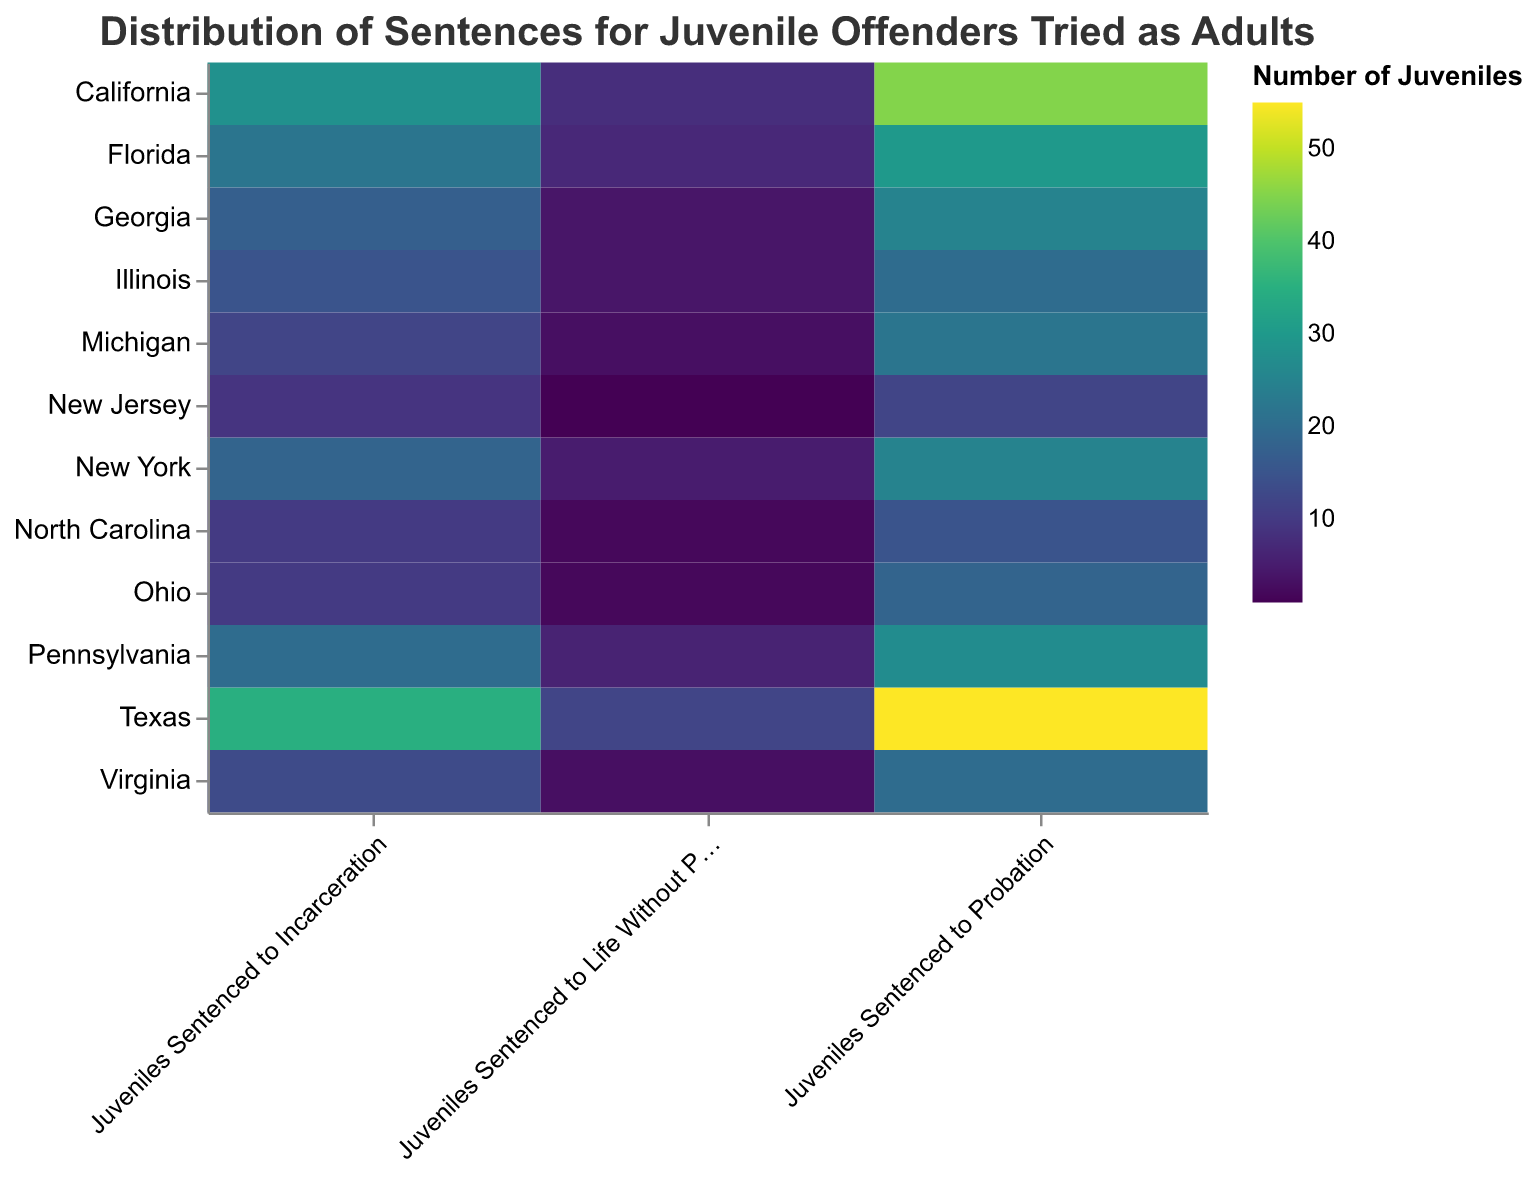What is the title of the figure? The title is typically found at the top of the figure. For this heatmap, it is clearly stated at the top.
Answer: Distribution of Sentences for Juvenile Offenders Tried as Adults Which state has the highest number of juveniles sentenced to probation? You can determine this by looking at the darkest color under the "Juveniles Sentenced to Probation" row. The state with the darkest color is Texas.
Answer: Texas How many states have juveniles sentenced to life without parole? Count the number of states listed on the y-axis where there is a color in the "Juveniles Sentenced to Life Without Parole" column.
Answer: 12 What is the total number of juveniles sentenced to incarceration in California and Texas combined? To calculate this, find the number of juveniles sentenced to incarceration in California (28) and Texas (35), and then add them together: 28 + 35 = 63.
Answer: 63 Which state has the least number of juveniles sentenced to life without parole? Look for the state with the lightest color under the "Juveniles Sentenced to Life Without Parole" column. New Jersey has the lightest color with only 1 juvenile sentenced to life without parole.
Answer: New Jersey Compare the number of juveniles sentenced to probation in Florida and New York. Which state has more? Locate the counts for Florida (30) and New York (25) under the "Juveniles Sentenced to Probation" column, and compare them. Florida has more juveniles sentenced to probation than New York.
Answer: Florida How many more juveniles are sentenced to life without parole in Texas than in Ohio? Find the counts for Texas (12) and Ohio (2) under the "Juveniles Sentenced to Life Without Parole" column, then subtract the latter from the former: 12 - 2 = 10.
Answer: 10 Identify the states with an equal number of juveniles sentenced to incarceration. Look for states with the same intensity of color under the "Juveniles Sentenced to Incarceration" column. Ohio and North Carolina each have 10 juveniles sentenced to incarceration, and Michigan and Virginia each have 13.
Answer: Ohio and North Carolina; Michigan and Virginia What is the average number of juveniles sentenced to probation across all listed states? Add the number of juveniles sentenced to probation for all states (45 + 55 + 30 + 25 + 20 + 18 + 27 + 22 + 25 + 15 + 12 + 20) and then divide by the total number of states (12). The sum is 314, so the average is 314 / 12 ≈ 26.17.
Answer: approximately 26.17 Which state has the second highest number of juveniles sentenced to life without parole? First identify the state with the highest number (Texas with 12), then locate the state with the next highest count (California with 8).
Answer: California 